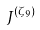<formula> <loc_0><loc_0><loc_500><loc_500>J ^ { ( \zeta _ { 9 } ) }</formula> 